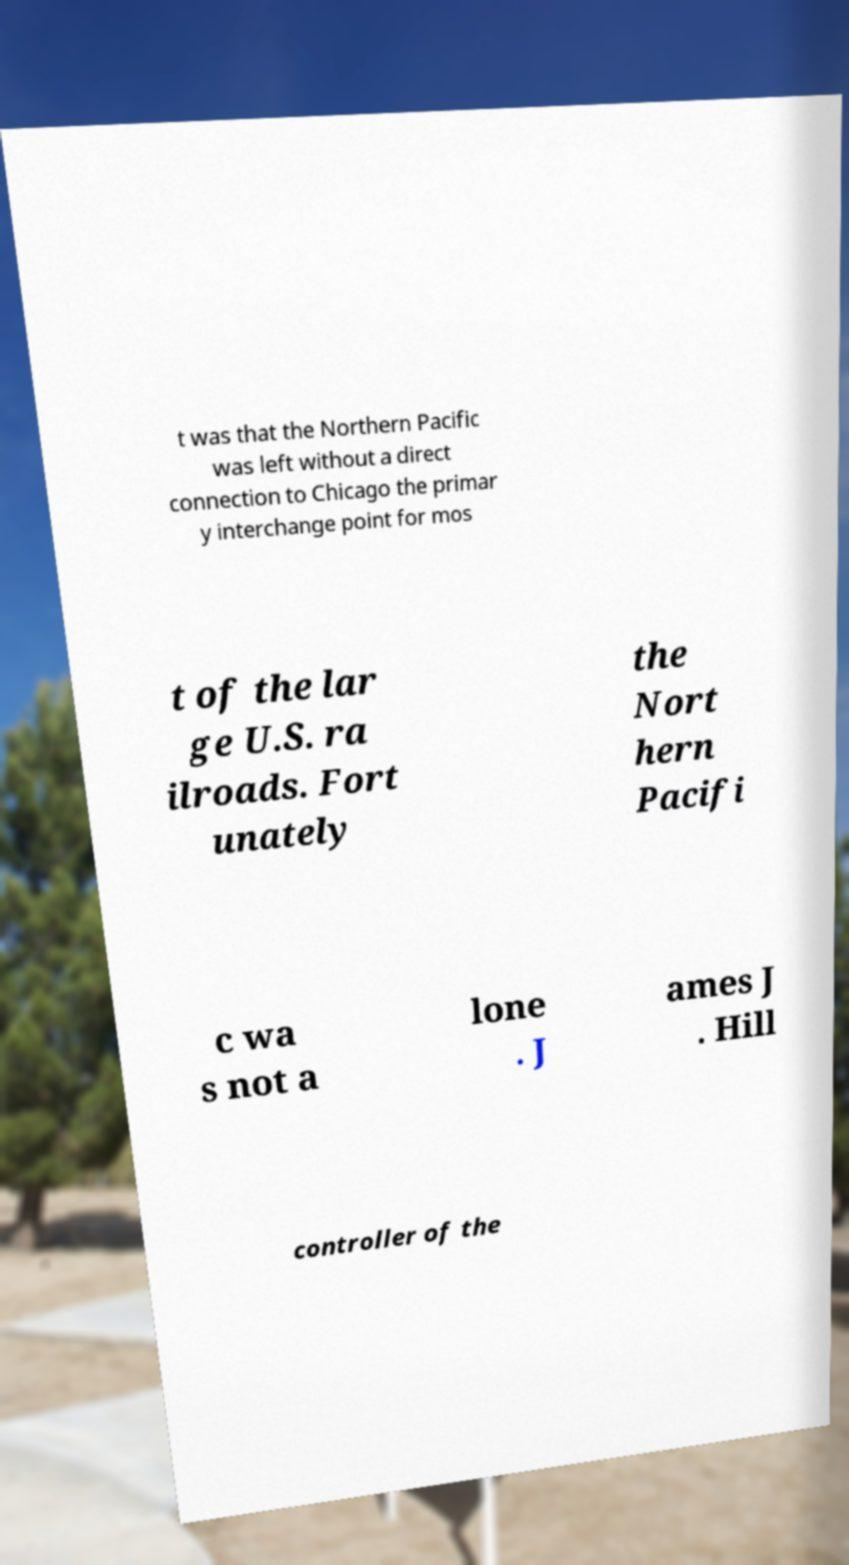Could you assist in decoding the text presented in this image and type it out clearly? t was that the Northern Pacific was left without a direct connection to Chicago the primar y interchange point for mos t of the lar ge U.S. ra ilroads. Fort unately the Nort hern Pacifi c wa s not a lone . J ames J . Hill controller of the 